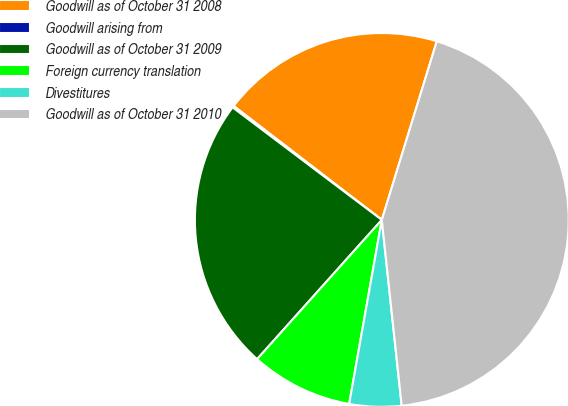Convert chart. <chart><loc_0><loc_0><loc_500><loc_500><pie_chart><fcel>Goodwill as of October 31 2008<fcel>Goodwill arising from<fcel>Goodwill as of October 31 2009<fcel>Foreign currency translation<fcel>Divestitures<fcel>Goodwill as of October 31 2010<nl><fcel>19.32%<fcel>0.15%<fcel>23.66%<fcel>8.83%<fcel>4.49%<fcel>43.55%<nl></chart> 